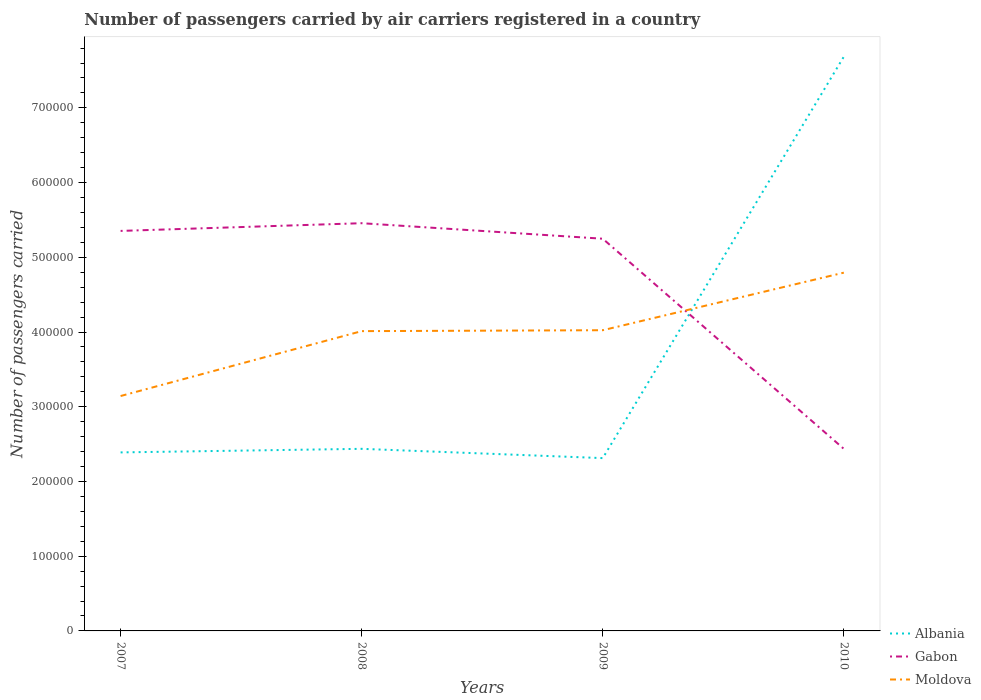Does the line corresponding to Moldova intersect with the line corresponding to Gabon?
Your answer should be compact. Yes. Is the number of lines equal to the number of legend labels?
Keep it short and to the point. Yes. Across all years, what is the maximum number of passengers carried by air carriers in Gabon?
Give a very brief answer. 2.44e+05. In which year was the number of passengers carried by air carriers in Moldova maximum?
Your answer should be very brief. 2007. What is the total number of passengers carried by air carriers in Moldova in the graph?
Your answer should be compact. -8.81e+04. What is the difference between the highest and the second highest number of passengers carried by air carriers in Gabon?
Your answer should be very brief. 3.02e+05. What is the difference between the highest and the lowest number of passengers carried by air carriers in Gabon?
Provide a short and direct response. 3. How many lines are there?
Provide a short and direct response. 3. How many years are there in the graph?
Provide a short and direct response. 4. Are the values on the major ticks of Y-axis written in scientific E-notation?
Offer a terse response. No. Does the graph contain any zero values?
Your response must be concise. No. Does the graph contain grids?
Your answer should be very brief. No. How are the legend labels stacked?
Keep it short and to the point. Vertical. What is the title of the graph?
Offer a terse response. Number of passengers carried by air carriers registered in a country. Does "Portugal" appear as one of the legend labels in the graph?
Your answer should be compact. No. What is the label or title of the Y-axis?
Provide a succinct answer. Number of passengers carried. What is the Number of passengers carried of Albania in 2007?
Offer a terse response. 2.39e+05. What is the Number of passengers carried in Gabon in 2007?
Make the answer very short. 5.35e+05. What is the Number of passengers carried in Moldova in 2007?
Offer a very short reply. 3.14e+05. What is the Number of passengers carried of Albania in 2008?
Your answer should be compact. 2.44e+05. What is the Number of passengers carried of Gabon in 2008?
Give a very brief answer. 5.46e+05. What is the Number of passengers carried of Moldova in 2008?
Offer a very short reply. 4.01e+05. What is the Number of passengers carried in Albania in 2009?
Your response must be concise. 2.31e+05. What is the Number of passengers carried in Gabon in 2009?
Keep it short and to the point. 5.25e+05. What is the Number of passengers carried in Moldova in 2009?
Your response must be concise. 4.02e+05. What is the Number of passengers carried of Albania in 2010?
Provide a short and direct response. 7.69e+05. What is the Number of passengers carried of Gabon in 2010?
Keep it short and to the point. 2.44e+05. What is the Number of passengers carried in Moldova in 2010?
Ensure brevity in your answer.  4.79e+05. Across all years, what is the maximum Number of passengers carried in Albania?
Provide a succinct answer. 7.69e+05. Across all years, what is the maximum Number of passengers carried in Gabon?
Offer a terse response. 5.46e+05. Across all years, what is the maximum Number of passengers carried of Moldova?
Provide a succinct answer. 4.79e+05. Across all years, what is the minimum Number of passengers carried in Albania?
Make the answer very short. 2.31e+05. Across all years, what is the minimum Number of passengers carried of Gabon?
Provide a short and direct response. 2.44e+05. Across all years, what is the minimum Number of passengers carried of Moldova?
Provide a succinct answer. 3.14e+05. What is the total Number of passengers carried in Albania in the graph?
Keep it short and to the point. 1.48e+06. What is the total Number of passengers carried of Gabon in the graph?
Your answer should be compact. 1.85e+06. What is the total Number of passengers carried of Moldova in the graph?
Your response must be concise. 1.60e+06. What is the difference between the Number of passengers carried of Albania in 2007 and that in 2008?
Provide a short and direct response. -4778. What is the difference between the Number of passengers carried of Gabon in 2007 and that in 2008?
Provide a short and direct response. -1.03e+04. What is the difference between the Number of passengers carried of Moldova in 2007 and that in 2008?
Provide a short and direct response. -8.68e+04. What is the difference between the Number of passengers carried in Albania in 2007 and that in 2009?
Your response must be concise. 7650. What is the difference between the Number of passengers carried in Gabon in 2007 and that in 2009?
Ensure brevity in your answer.  1.05e+04. What is the difference between the Number of passengers carried in Moldova in 2007 and that in 2009?
Give a very brief answer. -8.81e+04. What is the difference between the Number of passengers carried in Albania in 2007 and that in 2010?
Give a very brief answer. -5.30e+05. What is the difference between the Number of passengers carried of Gabon in 2007 and that in 2010?
Your answer should be very brief. 2.92e+05. What is the difference between the Number of passengers carried of Moldova in 2007 and that in 2010?
Provide a short and direct response. -1.65e+05. What is the difference between the Number of passengers carried in Albania in 2008 and that in 2009?
Offer a very short reply. 1.24e+04. What is the difference between the Number of passengers carried of Gabon in 2008 and that in 2009?
Your answer should be compact. 2.08e+04. What is the difference between the Number of passengers carried of Moldova in 2008 and that in 2009?
Make the answer very short. -1224. What is the difference between the Number of passengers carried in Albania in 2008 and that in 2010?
Your response must be concise. -5.25e+05. What is the difference between the Number of passengers carried in Gabon in 2008 and that in 2010?
Keep it short and to the point. 3.02e+05. What is the difference between the Number of passengers carried of Moldova in 2008 and that in 2010?
Give a very brief answer. -7.83e+04. What is the difference between the Number of passengers carried in Albania in 2009 and that in 2010?
Offer a very short reply. -5.37e+05. What is the difference between the Number of passengers carried in Gabon in 2009 and that in 2010?
Keep it short and to the point. 2.81e+05. What is the difference between the Number of passengers carried of Moldova in 2009 and that in 2010?
Your response must be concise. -7.70e+04. What is the difference between the Number of passengers carried of Albania in 2007 and the Number of passengers carried of Gabon in 2008?
Provide a short and direct response. -3.07e+05. What is the difference between the Number of passengers carried of Albania in 2007 and the Number of passengers carried of Moldova in 2008?
Provide a succinct answer. -1.62e+05. What is the difference between the Number of passengers carried of Gabon in 2007 and the Number of passengers carried of Moldova in 2008?
Offer a very short reply. 1.34e+05. What is the difference between the Number of passengers carried in Albania in 2007 and the Number of passengers carried in Gabon in 2009?
Your answer should be compact. -2.86e+05. What is the difference between the Number of passengers carried of Albania in 2007 and the Number of passengers carried of Moldova in 2009?
Make the answer very short. -1.64e+05. What is the difference between the Number of passengers carried of Gabon in 2007 and the Number of passengers carried of Moldova in 2009?
Your response must be concise. 1.33e+05. What is the difference between the Number of passengers carried of Albania in 2007 and the Number of passengers carried of Gabon in 2010?
Keep it short and to the point. -4722.53. What is the difference between the Number of passengers carried in Albania in 2007 and the Number of passengers carried in Moldova in 2010?
Provide a succinct answer. -2.41e+05. What is the difference between the Number of passengers carried in Gabon in 2007 and the Number of passengers carried in Moldova in 2010?
Provide a succinct answer. 5.59e+04. What is the difference between the Number of passengers carried of Albania in 2008 and the Number of passengers carried of Gabon in 2009?
Your response must be concise. -2.81e+05. What is the difference between the Number of passengers carried in Albania in 2008 and the Number of passengers carried in Moldova in 2009?
Provide a short and direct response. -1.59e+05. What is the difference between the Number of passengers carried of Gabon in 2008 and the Number of passengers carried of Moldova in 2009?
Offer a terse response. 1.43e+05. What is the difference between the Number of passengers carried of Albania in 2008 and the Number of passengers carried of Gabon in 2010?
Provide a short and direct response. 55.47. What is the difference between the Number of passengers carried of Albania in 2008 and the Number of passengers carried of Moldova in 2010?
Provide a succinct answer. -2.36e+05. What is the difference between the Number of passengers carried of Gabon in 2008 and the Number of passengers carried of Moldova in 2010?
Your response must be concise. 6.62e+04. What is the difference between the Number of passengers carried of Albania in 2009 and the Number of passengers carried of Gabon in 2010?
Keep it short and to the point. -1.24e+04. What is the difference between the Number of passengers carried in Albania in 2009 and the Number of passengers carried in Moldova in 2010?
Provide a succinct answer. -2.48e+05. What is the difference between the Number of passengers carried of Gabon in 2009 and the Number of passengers carried of Moldova in 2010?
Your answer should be compact. 4.54e+04. What is the average Number of passengers carried in Albania per year?
Offer a terse response. 3.71e+05. What is the average Number of passengers carried of Gabon per year?
Offer a very short reply. 4.62e+05. What is the average Number of passengers carried in Moldova per year?
Keep it short and to the point. 3.99e+05. In the year 2007, what is the difference between the Number of passengers carried in Albania and Number of passengers carried in Gabon?
Your response must be concise. -2.96e+05. In the year 2007, what is the difference between the Number of passengers carried in Albania and Number of passengers carried in Moldova?
Ensure brevity in your answer.  -7.54e+04. In the year 2007, what is the difference between the Number of passengers carried in Gabon and Number of passengers carried in Moldova?
Your response must be concise. 2.21e+05. In the year 2008, what is the difference between the Number of passengers carried in Albania and Number of passengers carried in Gabon?
Your answer should be very brief. -3.02e+05. In the year 2008, what is the difference between the Number of passengers carried in Albania and Number of passengers carried in Moldova?
Your response must be concise. -1.58e+05. In the year 2008, what is the difference between the Number of passengers carried in Gabon and Number of passengers carried in Moldova?
Your answer should be compact. 1.44e+05. In the year 2009, what is the difference between the Number of passengers carried of Albania and Number of passengers carried of Gabon?
Keep it short and to the point. -2.94e+05. In the year 2009, what is the difference between the Number of passengers carried of Albania and Number of passengers carried of Moldova?
Provide a short and direct response. -1.71e+05. In the year 2009, what is the difference between the Number of passengers carried of Gabon and Number of passengers carried of Moldova?
Your answer should be compact. 1.22e+05. In the year 2010, what is the difference between the Number of passengers carried in Albania and Number of passengers carried in Gabon?
Make the answer very short. 5.25e+05. In the year 2010, what is the difference between the Number of passengers carried in Albania and Number of passengers carried in Moldova?
Keep it short and to the point. 2.89e+05. In the year 2010, what is the difference between the Number of passengers carried in Gabon and Number of passengers carried in Moldova?
Offer a terse response. -2.36e+05. What is the ratio of the Number of passengers carried of Albania in 2007 to that in 2008?
Provide a short and direct response. 0.98. What is the ratio of the Number of passengers carried of Gabon in 2007 to that in 2008?
Provide a short and direct response. 0.98. What is the ratio of the Number of passengers carried of Moldova in 2007 to that in 2008?
Provide a succinct answer. 0.78. What is the ratio of the Number of passengers carried in Albania in 2007 to that in 2009?
Provide a short and direct response. 1.03. What is the ratio of the Number of passengers carried of Gabon in 2007 to that in 2009?
Provide a short and direct response. 1.02. What is the ratio of the Number of passengers carried of Moldova in 2007 to that in 2009?
Offer a very short reply. 0.78. What is the ratio of the Number of passengers carried of Albania in 2007 to that in 2010?
Your answer should be very brief. 0.31. What is the ratio of the Number of passengers carried in Gabon in 2007 to that in 2010?
Make the answer very short. 2.2. What is the ratio of the Number of passengers carried of Moldova in 2007 to that in 2010?
Your response must be concise. 0.66. What is the ratio of the Number of passengers carried in Albania in 2008 to that in 2009?
Offer a terse response. 1.05. What is the ratio of the Number of passengers carried of Gabon in 2008 to that in 2009?
Offer a very short reply. 1.04. What is the ratio of the Number of passengers carried of Albania in 2008 to that in 2010?
Keep it short and to the point. 0.32. What is the ratio of the Number of passengers carried in Gabon in 2008 to that in 2010?
Your answer should be very brief. 2.24. What is the ratio of the Number of passengers carried of Moldova in 2008 to that in 2010?
Ensure brevity in your answer.  0.84. What is the ratio of the Number of passengers carried in Albania in 2009 to that in 2010?
Provide a succinct answer. 0.3. What is the ratio of the Number of passengers carried of Gabon in 2009 to that in 2010?
Keep it short and to the point. 2.15. What is the ratio of the Number of passengers carried of Moldova in 2009 to that in 2010?
Your response must be concise. 0.84. What is the difference between the highest and the second highest Number of passengers carried in Albania?
Keep it short and to the point. 5.25e+05. What is the difference between the highest and the second highest Number of passengers carried in Gabon?
Your answer should be very brief. 1.03e+04. What is the difference between the highest and the second highest Number of passengers carried of Moldova?
Ensure brevity in your answer.  7.70e+04. What is the difference between the highest and the lowest Number of passengers carried in Albania?
Provide a short and direct response. 5.37e+05. What is the difference between the highest and the lowest Number of passengers carried of Gabon?
Your response must be concise. 3.02e+05. What is the difference between the highest and the lowest Number of passengers carried of Moldova?
Provide a short and direct response. 1.65e+05. 